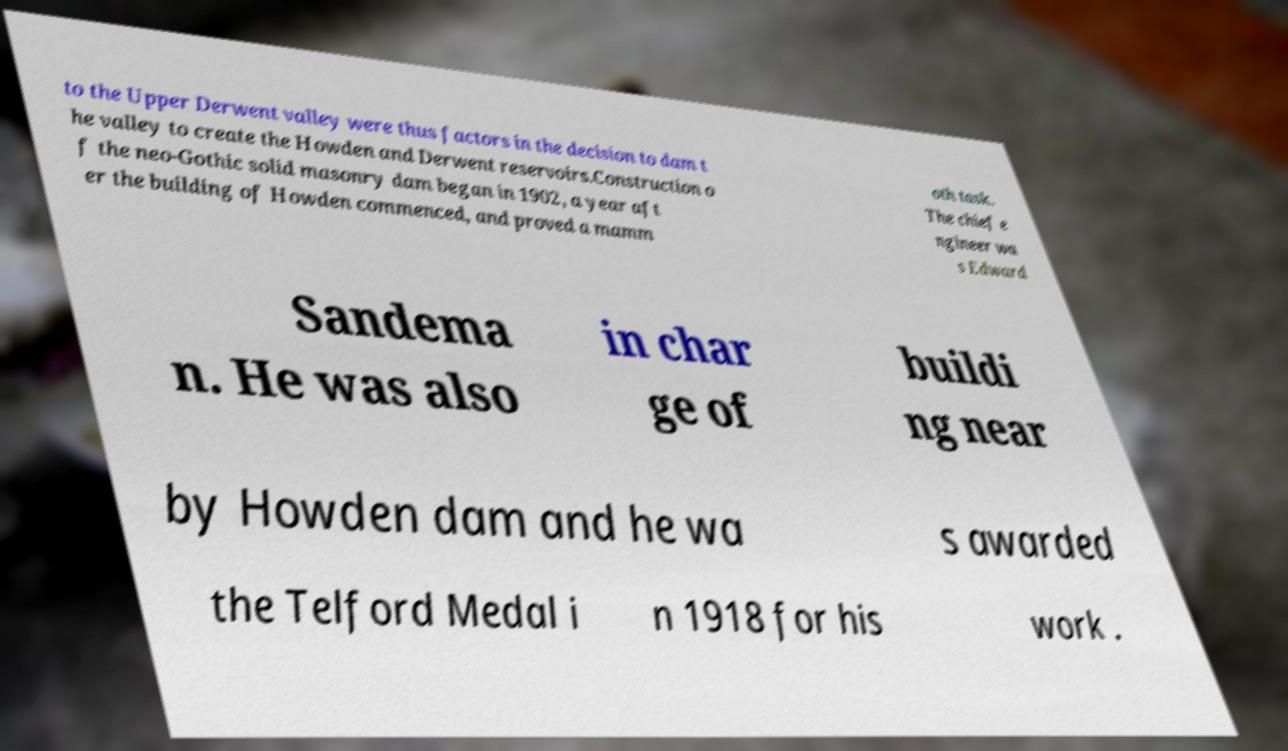Could you extract and type out the text from this image? to the Upper Derwent valley were thus factors in the decision to dam t he valley to create the Howden and Derwent reservoirs.Construction o f the neo-Gothic solid masonry dam began in 1902, a year aft er the building of Howden commenced, and proved a mamm oth task. The chief e ngineer wa s Edward Sandema n. He was also in char ge of buildi ng near by Howden dam and he wa s awarded the Telford Medal i n 1918 for his work . 